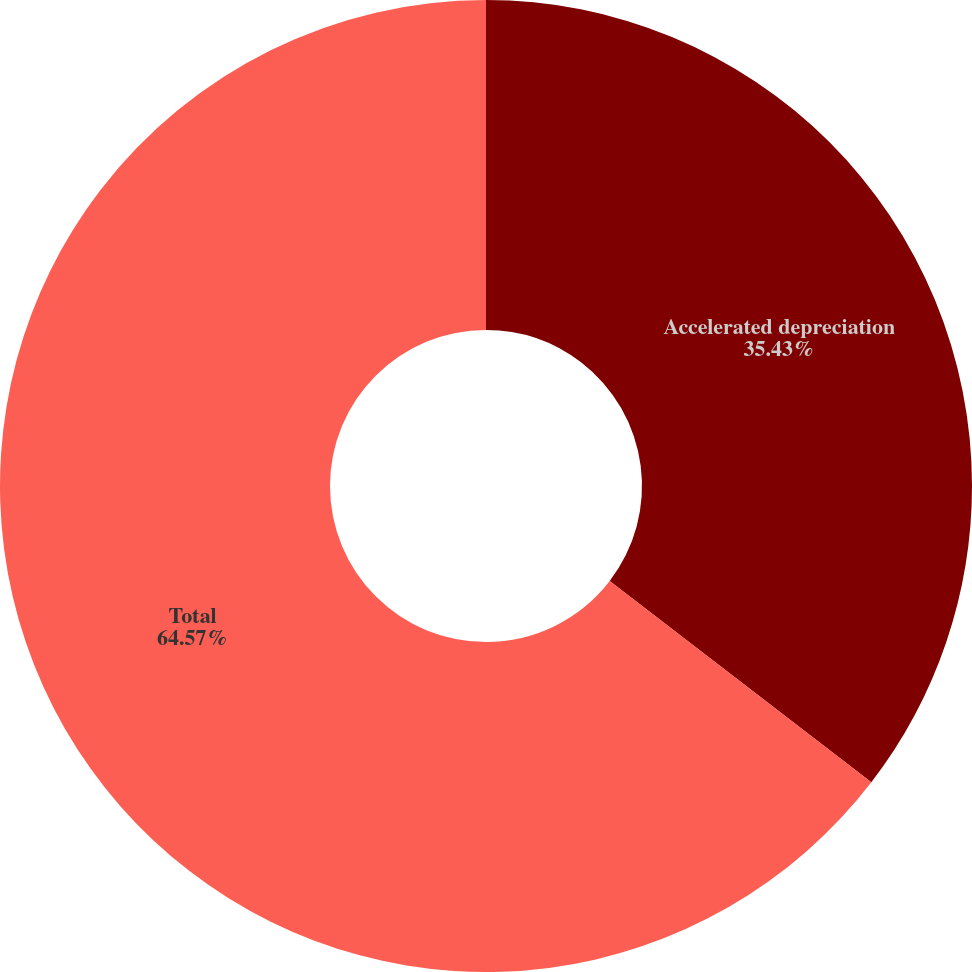<chart> <loc_0><loc_0><loc_500><loc_500><pie_chart><fcel>Accelerated depreciation<fcel>Total<nl><fcel>35.43%<fcel>64.57%<nl></chart> 